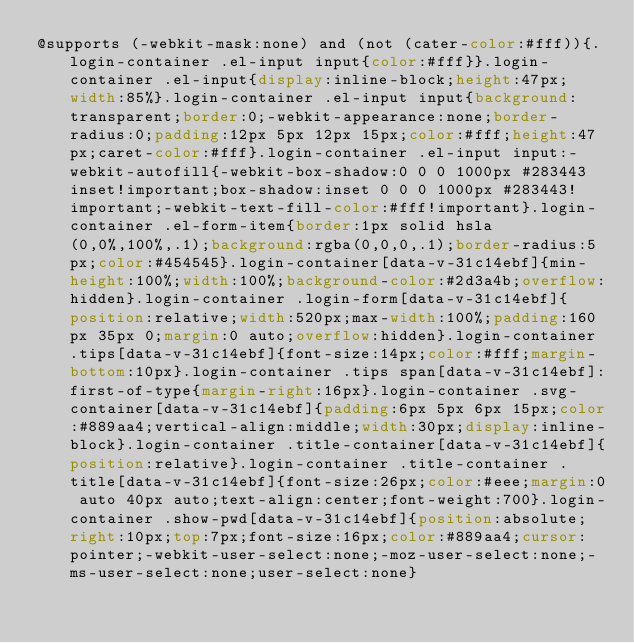<code> <loc_0><loc_0><loc_500><loc_500><_CSS_>@supports (-webkit-mask:none) and (not (cater-color:#fff)){.login-container .el-input input{color:#fff}}.login-container .el-input{display:inline-block;height:47px;width:85%}.login-container .el-input input{background:transparent;border:0;-webkit-appearance:none;border-radius:0;padding:12px 5px 12px 15px;color:#fff;height:47px;caret-color:#fff}.login-container .el-input input:-webkit-autofill{-webkit-box-shadow:0 0 0 1000px #283443 inset!important;box-shadow:inset 0 0 0 1000px #283443!important;-webkit-text-fill-color:#fff!important}.login-container .el-form-item{border:1px solid hsla(0,0%,100%,.1);background:rgba(0,0,0,.1);border-radius:5px;color:#454545}.login-container[data-v-31c14ebf]{min-height:100%;width:100%;background-color:#2d3a4b;overflow:hidden}.login-container .login-form[data-v-31c14ebf]{position:relative;width:520px;max-width:100%;padding:160px 35px 0;margin:0 auto;overflow:hidden}.login-container .tips[data-v-31c14ebf]{font-size:14px;color:#fff;margin-bottom:10px}.login-container .tips span[data-v-31c14ebf]:first-of-type{margin-right:16px}.login-container .svg-container[data-v-31c14ebf]{padding:6px 5px 6px 15px;color:#889aa4;vertical-align:middle;width:30px;display:inline-block}.login-container .title-container[data-v-31c14ebf]{position:relative}.login-container .title-container .title[data-v-31c14ebf]{font-size:26px;color:#eee;margin:0 auto 40px auto;text-align:center;font-weight:700}.login-container .show-pwd[data-v-31c14ebf]{position:absolute;right:10px;top:7px;font-size:16px;color:#889aa4;cursor:pointer;-webkit-user-select:none;-moz-user-select:none;-ms-user-select:none;user-select:none}</code> 